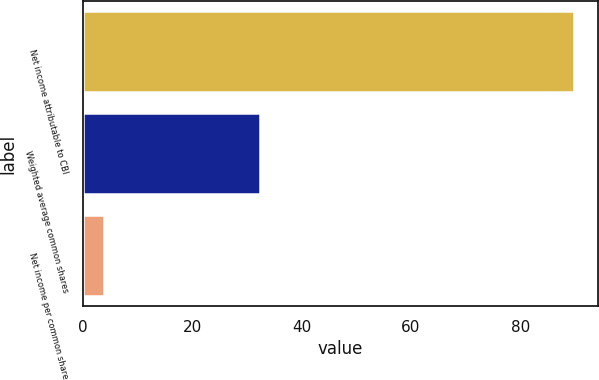Convert chart to OTSL. <chart><loc_0><loc_0><loc_500><loc_500><bar_chart><fcel>Net income attributable to CBI<fcel>Weighted average common shares<fcel>Net income per common share<nl><fcel>89.7<fcel>32.39<fcel>3.83<nl></chart> 